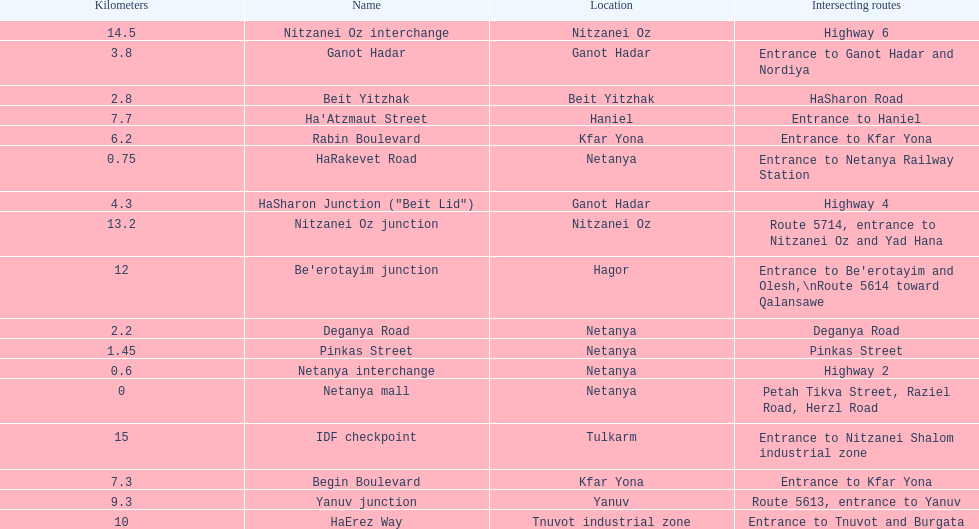After you complete deganya road, what portion comes next? Beit Yitzhak. 